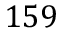Convert formula to latex. <formula><loc_0><loc_0><loc_500><loc_500>1 5 9</formula> 